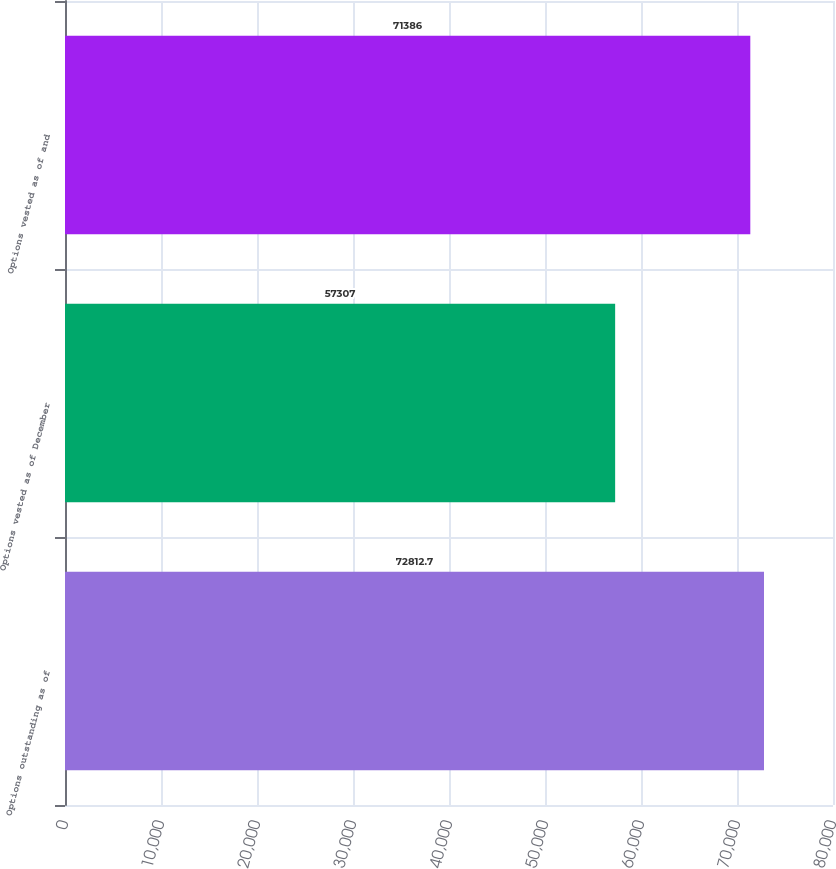<chart> <loc_0><loc_0><loc_500><loc_500><bar_chart><fcel>Options outstanding as of<fcel>Options vested as of December<fcel>Options vested as of and<nl><fcel>72812.7<fcel>57307<fcel>71386<nl></chart> 